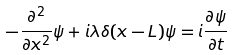<formula> <loc_0><loc_0><loc_500><loc_500>- \frac { \partial ^ { 2 } } { \partial x ^ { 2 } } \psi + i \lambda \delta ( x - L ) \psi = i \frac { \partial \psi } { \partial t }</formula> 